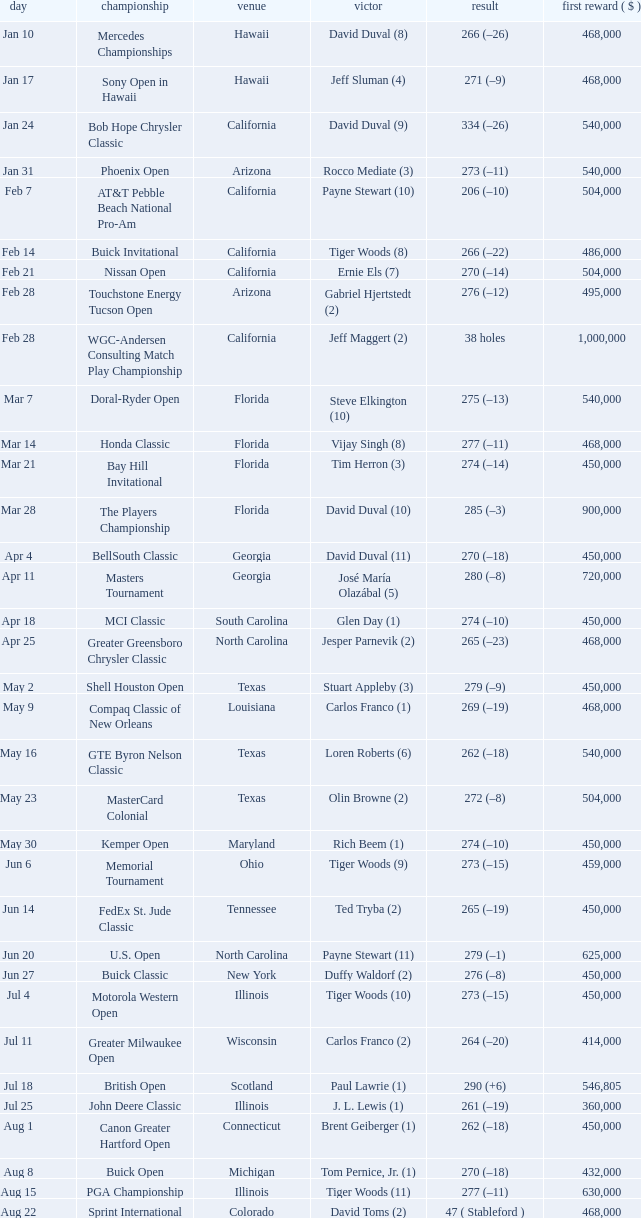Who claimed the championship in the october 3rd georgia tournament? David Toms (3). 